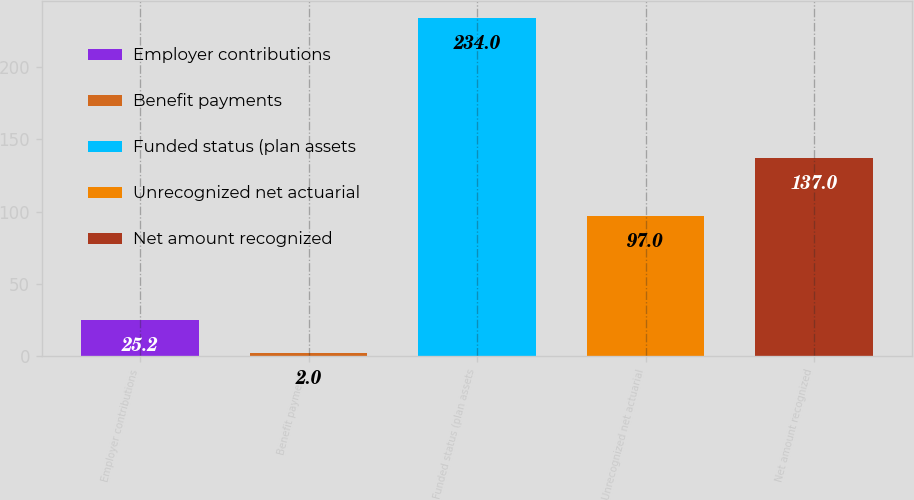<chart> <loc_0><loc_0><loc_500><loc_500><bar_chart><fcel>Employer contributions<fcel>Benefit payments<fcel>Funded status (plan assets<fcel>Unrecognized net actuarial<fcel>Net amount recognized<nl><fcel>25.2<fcel>2<fcel>234<fcel>97<fcel>137<nl></chart> 